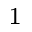Convert formula to latex. <formula><loc_0><loc_0><loc_500><loc_500>_ { 1 }</formula> 